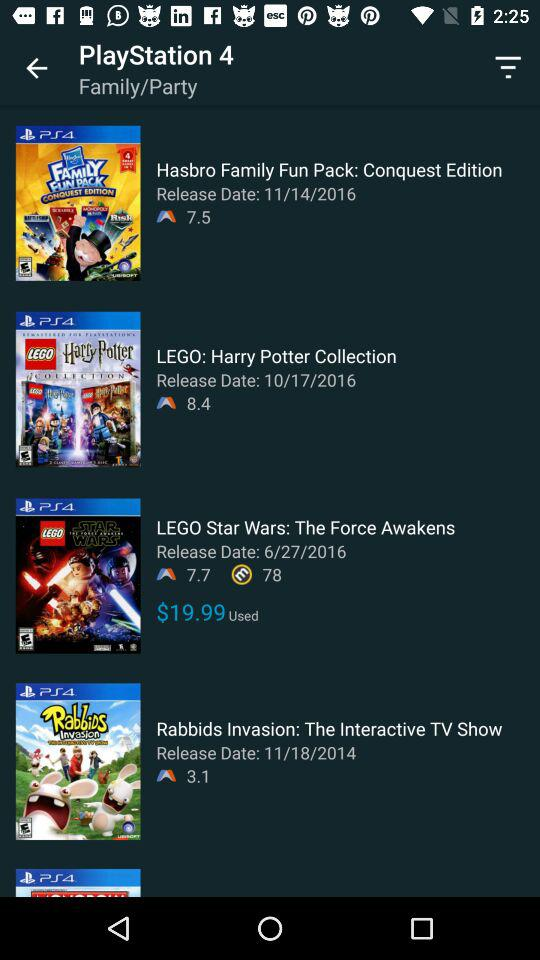What is the price of "LEGO Star Wars"? The price of "LEGO Star Wars" is $19.99. 